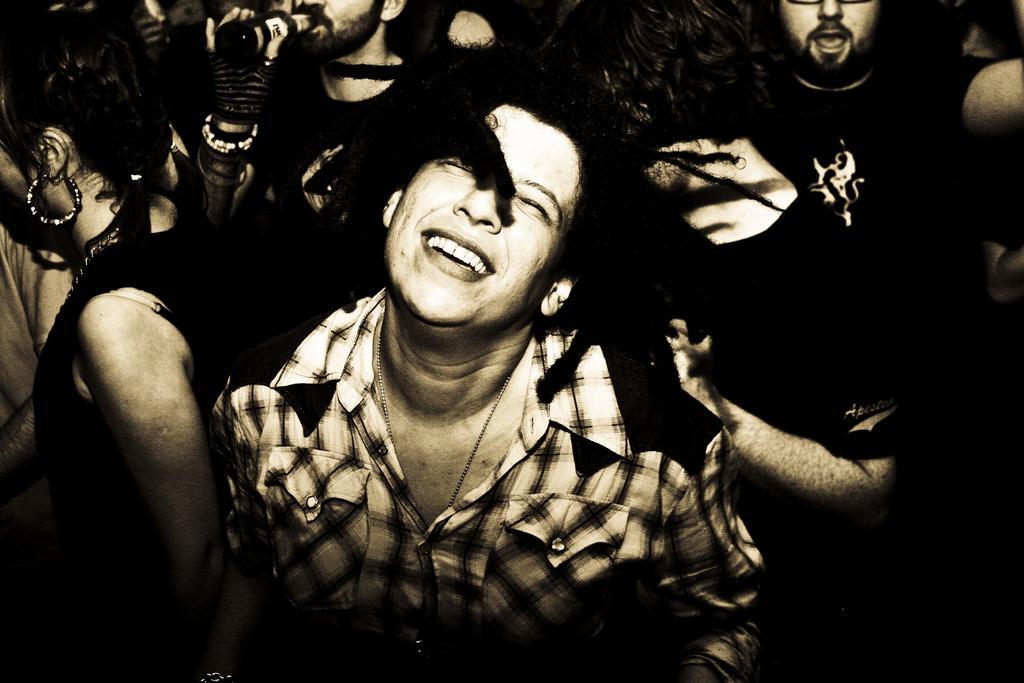In one or two sentences, can you explain what this image depicts? In this image we can see a group of persons. At the top we can see a person holding a bottle. 